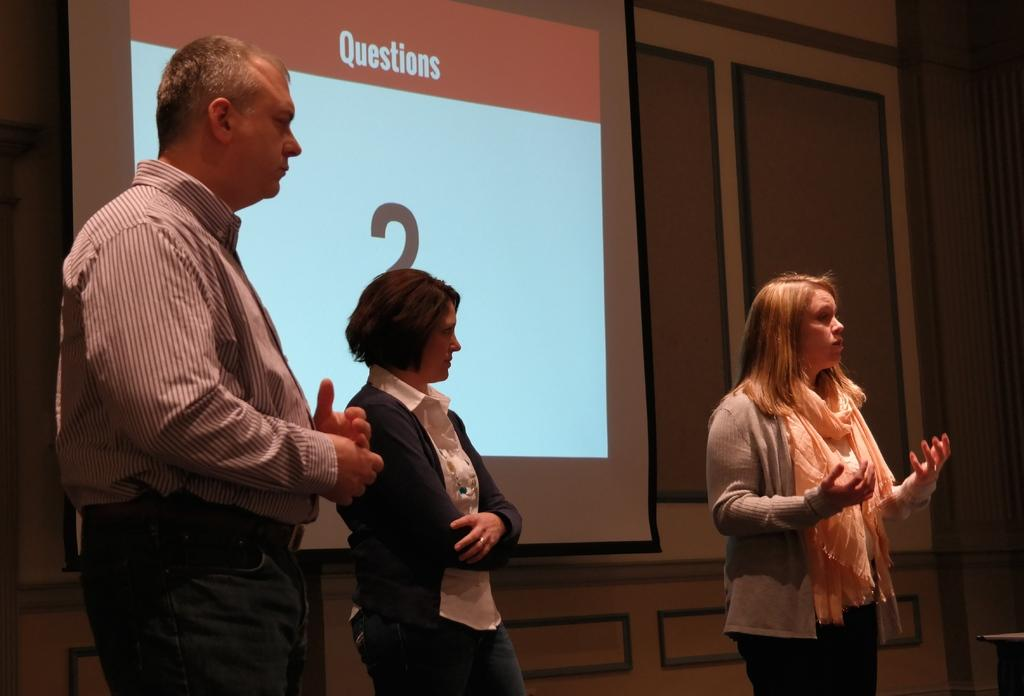How many people are in the image? There are persons standing in the image. What are the persons wearing? The persons are wearing clothes. What can be seen on the wall in the image? There is a screen on the wall in the image. What type of pencil is being used by the authority figure in the image? There is no authority figure or pencil present in the image. 